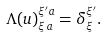<formula> <loc_0><loc_0><loc_500><loc_500>\Lambda ( u ) ^ { \xi ^ { \prime } a } _ { \xi \, a } = \delta ^ { \xi ^ { \prime } } _ { \xi } .</formula> 